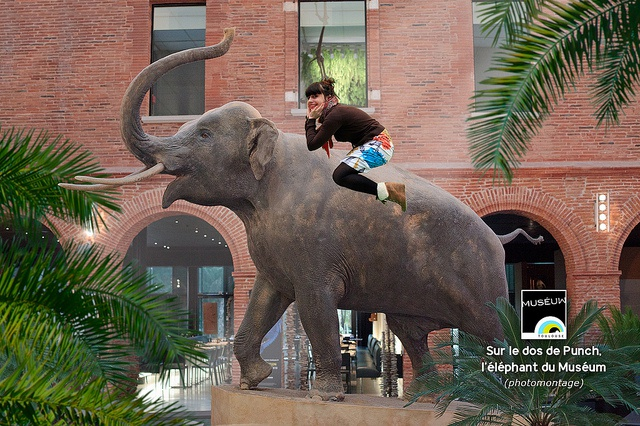Describe the objects in this image and their specific colors. I can see elephant in tan, gray, and black tones, people in tan, black, maroon, lightgray, and brown tones, bench in tan, black, gray, purple, and darkgray tones, chair in tan, gray, darkgray, ivory, and darkgreen tones, and dining table in tan, black, gray, darkgray, and white tones in this image. 